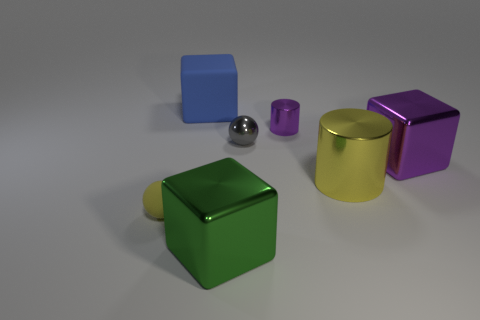Add 3 tiny gray objects. How many objects exist? 10 Subtract all balls. How many objects are left? 5 Subtract 0 cyan cubes. How many objects are left? 7 Subtract all small yellow spheres. Subtract all tiny yellow objects. How many objects are left? 5 Add 1 large green shiny things. How many large green shiny things are left? 2 Add 6 brown objects. How many brown objects exist? 6 